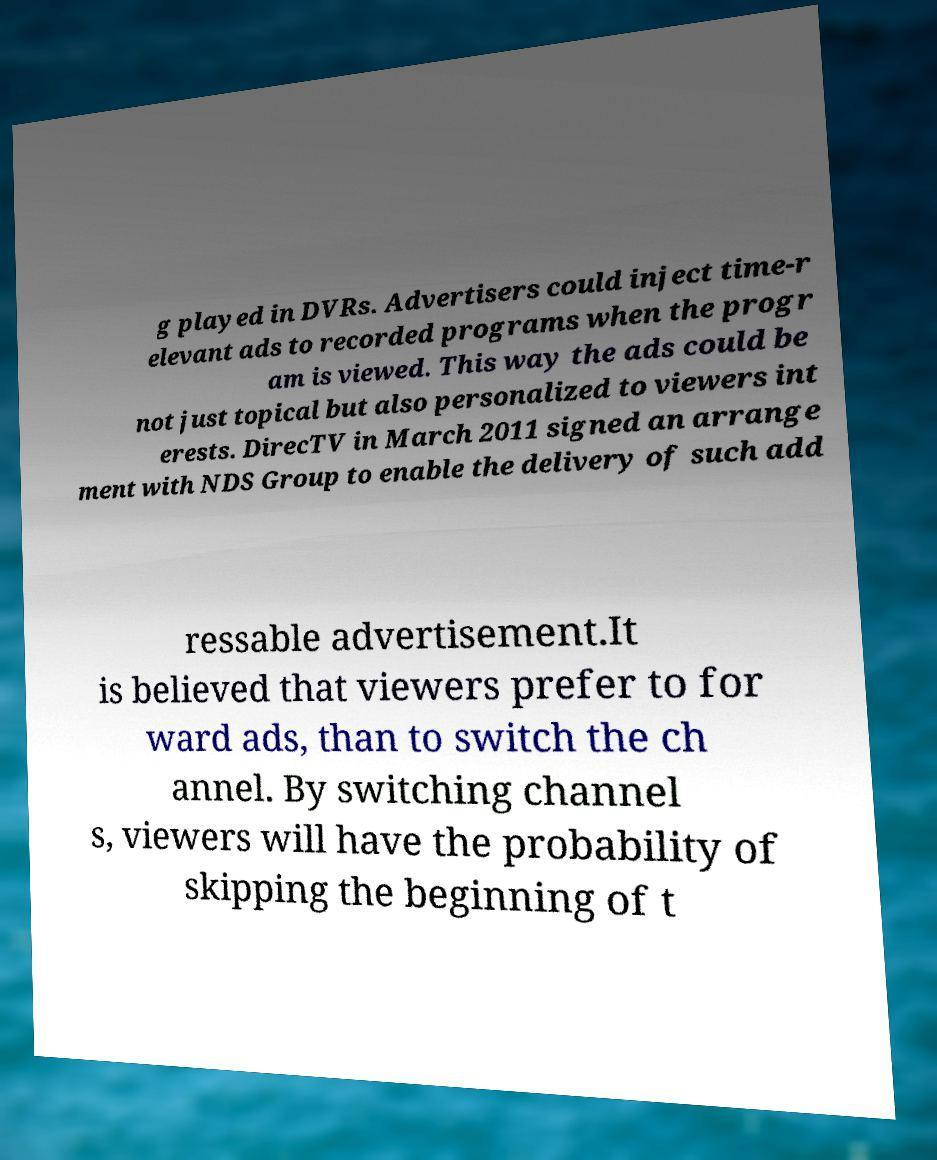There's text embedded in this image that I need extracted. Can you transcribe it verbatim? g played in DVRs. Advertisers could inject time-r elevant ads to recorded programs when the progr am is viewed. This way the ads could be not just topical but also personalized to viewers int erests. DirecTV in March 2011 signed an arrange ment with NDS Group to enable the delivery of such add ressable advertisement.It is believed that viewers prefer to for ward ads, than to switch the ch annel. By switching channel s, viewers will have the probability of skipping the beginning of t 